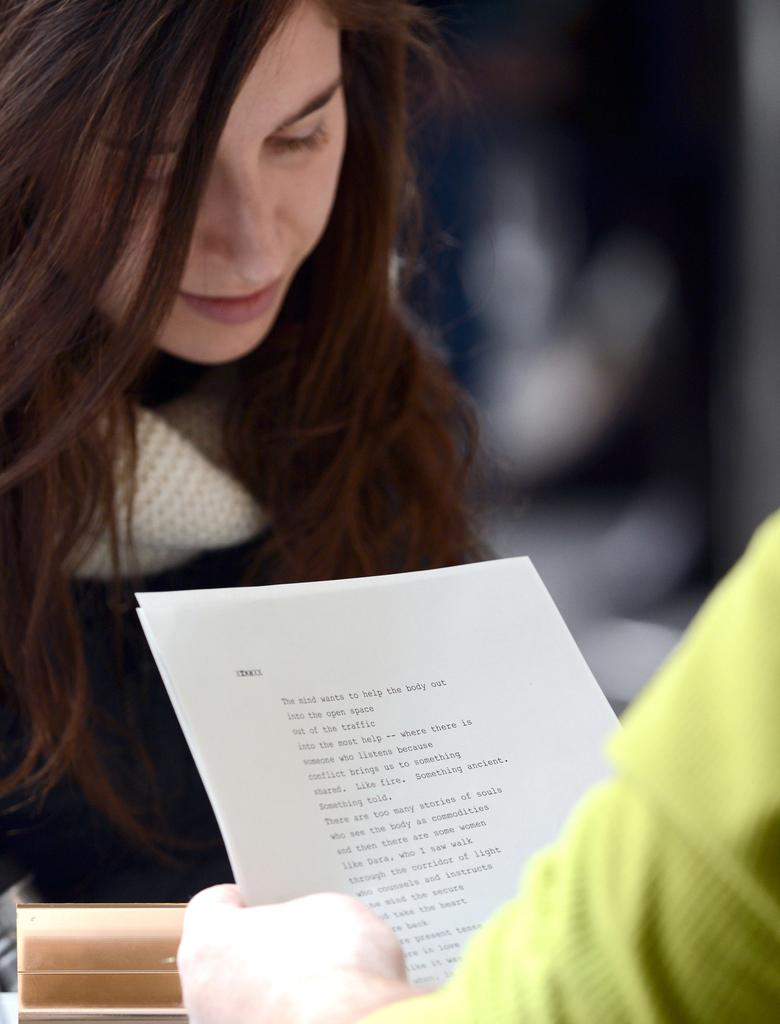How many people are in the image? There are two persons in the image. What are the persons holding in their hands? The persons are holding papers in their hands. What can be inferred about the lighting in the image? The background of the image is dark in color. What type of location might the image be taken in? The image appears to be taken in a hall. What type of activity can be seen taking place in the waves in the image? There are no waves present in the image, as it appears to be taken in a hall. How do the persons maintain their balance while holding the papers in the image? The persons are not shown performing any balancing act in the image; they are simply holding papers in their hands. 